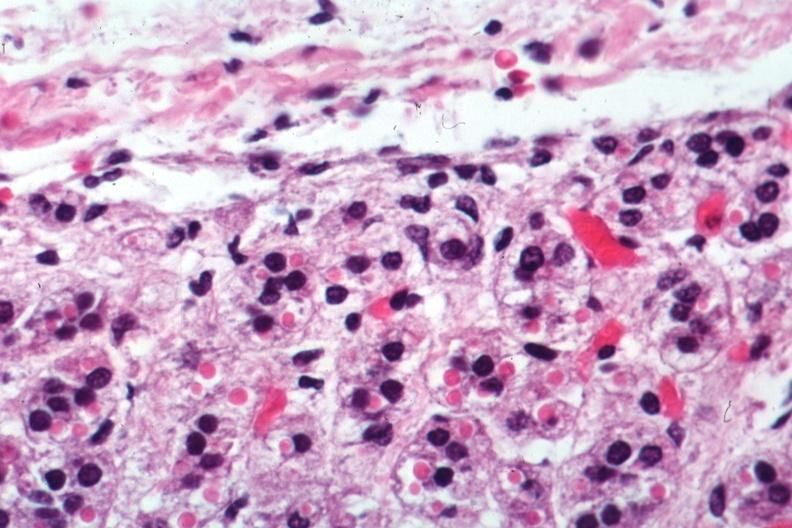s pus in test tube present?
Answer the question using a single word or phrase. No 